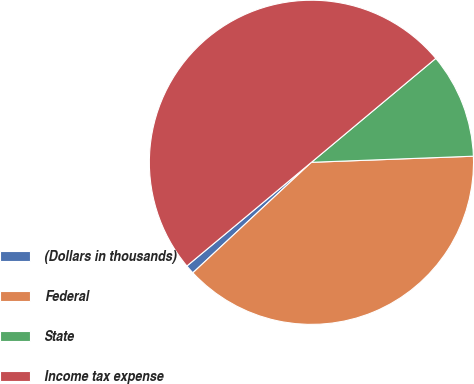<chart> <loc_0><loc_0><loc_500><loc_500><pie_chart><fcel>(Dollars in thousands)<fcel>Federal<fcel>State<fcel>Income tax expense<nl><fcel>0.89%<fcel>38.66%<fcel>10.48%<fcel>49.97%<nl></chart> 